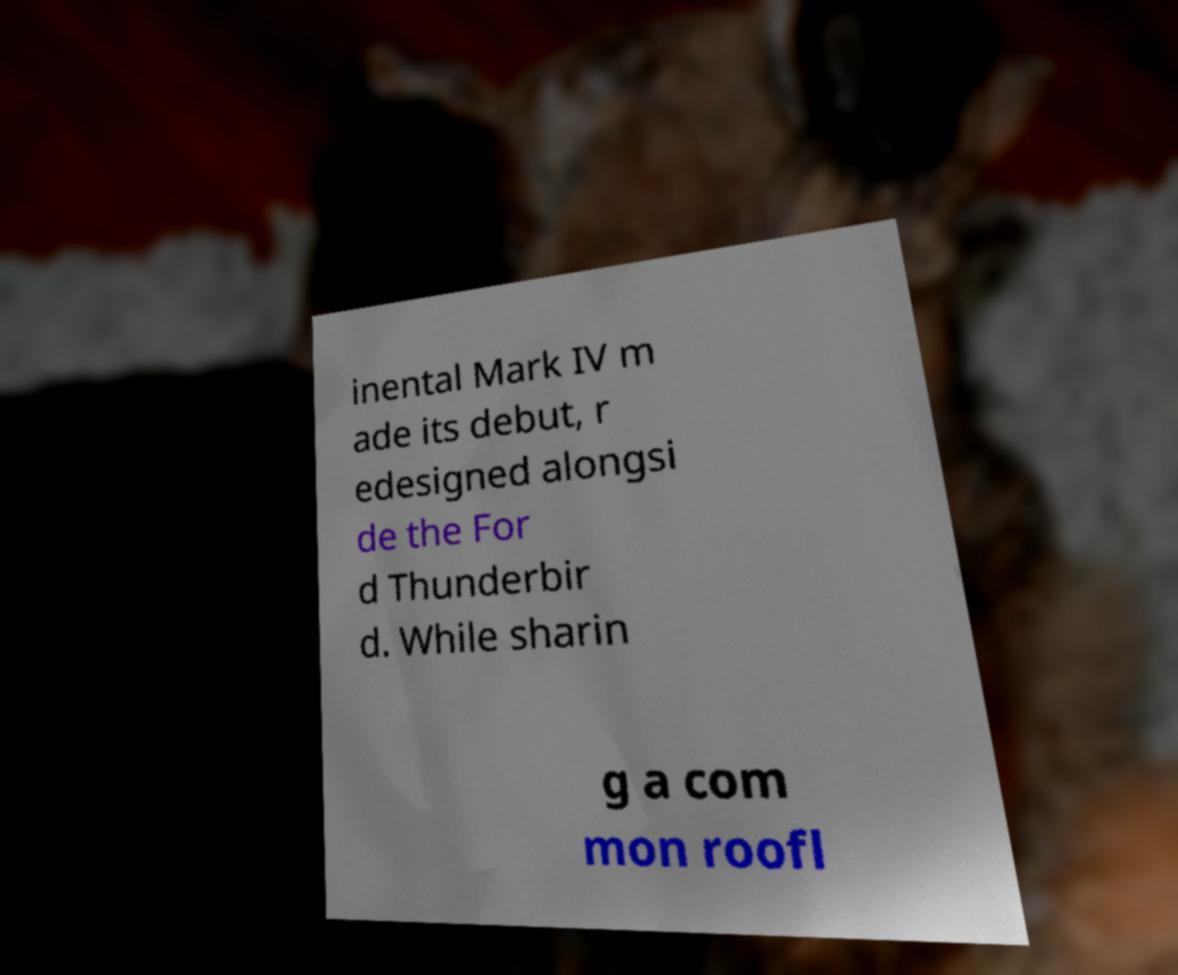For documentation purposes, I need the text within this image transcribed. Could you provide that? inental Mark IV m ade its debut, r edesigned alongsi de the For d Thunderbir d. While sharin g a com mon roofl 